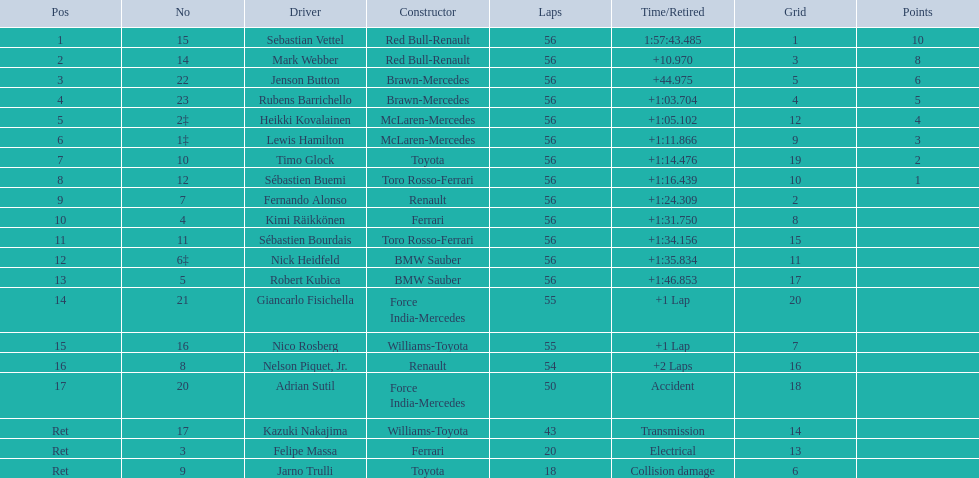What was jenson button's race time? +44.975. 